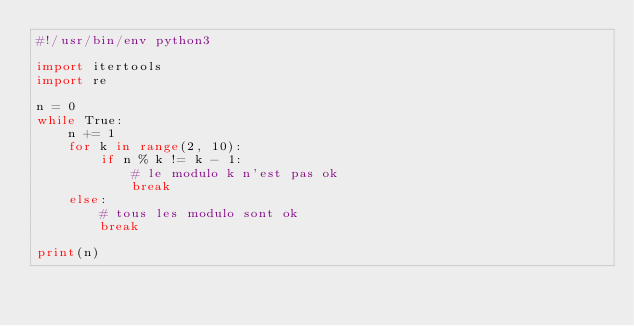Convert code to text. <code><loc_0><loc_0><loc_500><loc_500><_Python_>#!/usr/bin/env python3

import itertools
import re

n = 0
while True:
    n += 1
    for k in range(2, 10):
        if n % k != k - 1:
            # le modulo k n'est pas ok
            break
    else:
        # tous les modulo sont ok
        break

print(n)
</code> 